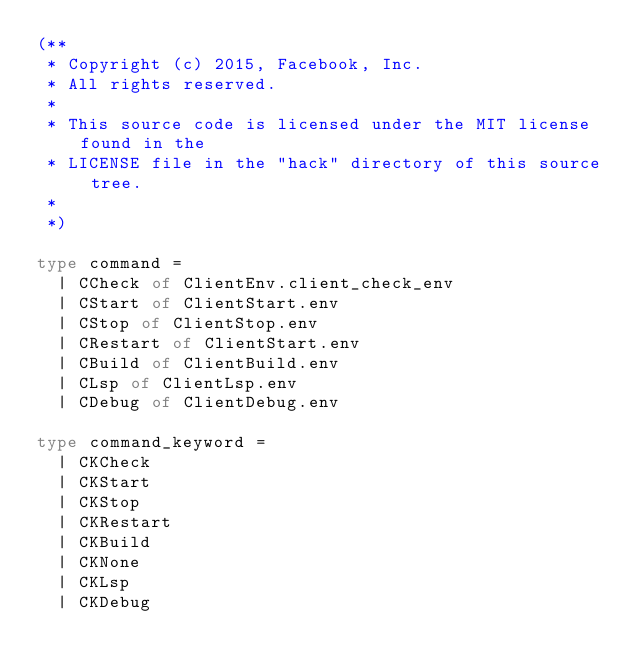Convert code to text. <code><loc_0><loc_0><loc_500><loc_500><_OCaml_>(**
 * Copyright (c) 2015, Facebook, Inc.
 * All rights reserved.
 *
 * This source code is licensed under the MIT license found in the
 * LICENSE file in the "hack" directory of this source tree.
 *
 *)

type command =
  | CCheck of ClientEnv.client_check_env
  | CStart of ClientStart.env
  | CStop of ClientStop.env
  | CRestart of ClientStart.env
  | CBuild of ClientBuild.env
  | CLsp of ClientLsp.env
  | CDebug of ClientDebug.env

type command_keyword =
  | CKCheck
  | CKStart
  | CKStop
  | CKRestart
  | CKBuild
  | CKNone
  | CKLsp
  | CKDebug
</code> 